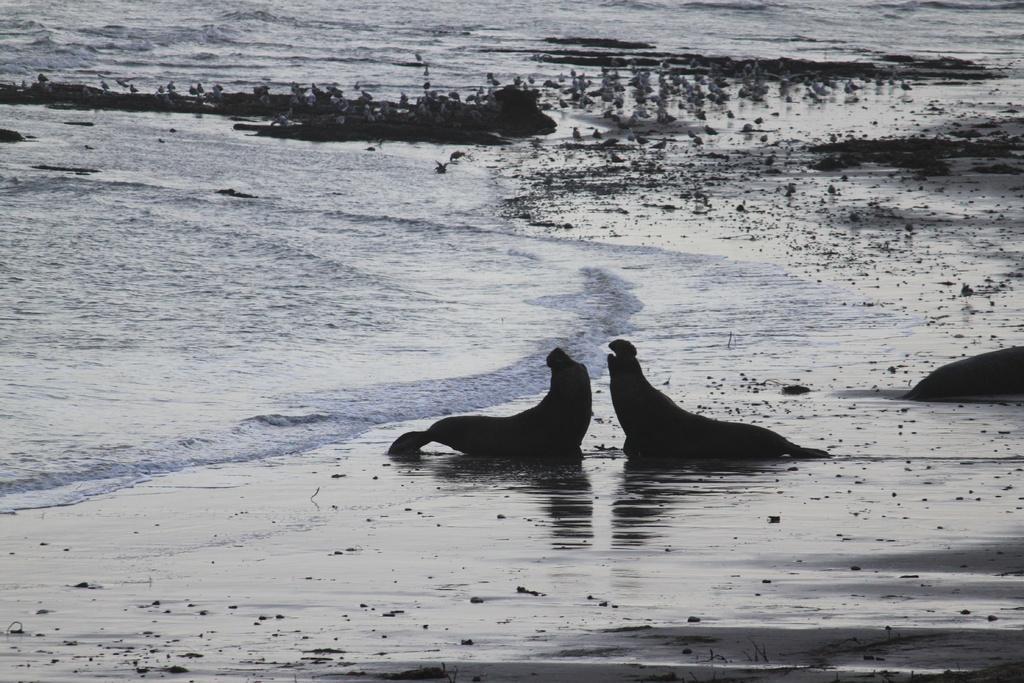Describe this image in one or two sentences. In this picture we can see animals on sand and in the background we can see water. 